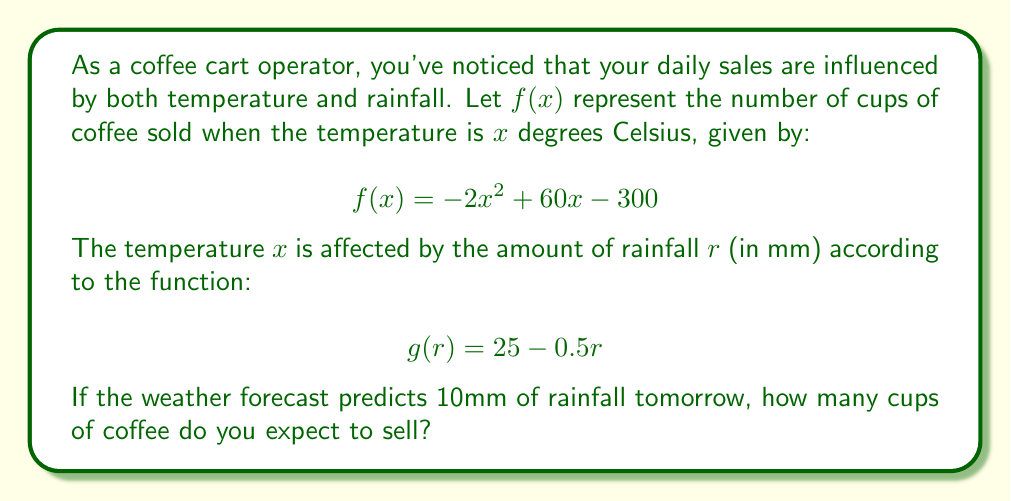Solve this math problem. To solve this problem, we need to use a composite function. We'll compose $f(x)$ with $g(r)$ to create $(f \circ g)(r)$, which will give us the number of cups sold based on rainfall.

Step 1: Find the temperature given the rainfall.
$g(10) = 25 - 0.5(10) = 25 - 5 = 20$
So, when there's 10mm of rainfall, the temperature will be 20°C.

Step 2: Create the composite function $(f \circ g)(r)$.
$$(f \circ g)(r) = f(g(r)) = f(25 - 0.5r)$$

Step 3: Substitute $g(r)$ into $f(x)$.
$$(f \circ g)(r) = -2(25 - 0.5r)^2 + 60(25 - 0.5r) - 300$$

Step 4: Simplify the composite function.
$$(f \circ g)(r) = -2(625 - 25r + 0.25r^2) + 1500 - 30r - 300$$
$$(f \circ g)(r) = -1250 + 50r - 0.5r^2 + 1500 - 30r - 300$$
$$(f \circ g)(r) = -0.5r^2 + 20r - 50$$

Step 5: Calculate the number of cups sold when $r = 10$.
$$(f \circ g)(10) = -0.5(10)^2 + 20(10) - 50$$
$$(f \circ g)(10) = -50 + 200 - 50 = 100$$

Therefore, you expect to sell 100 cups of coffee tomorrow.
Answer: 100 cups 